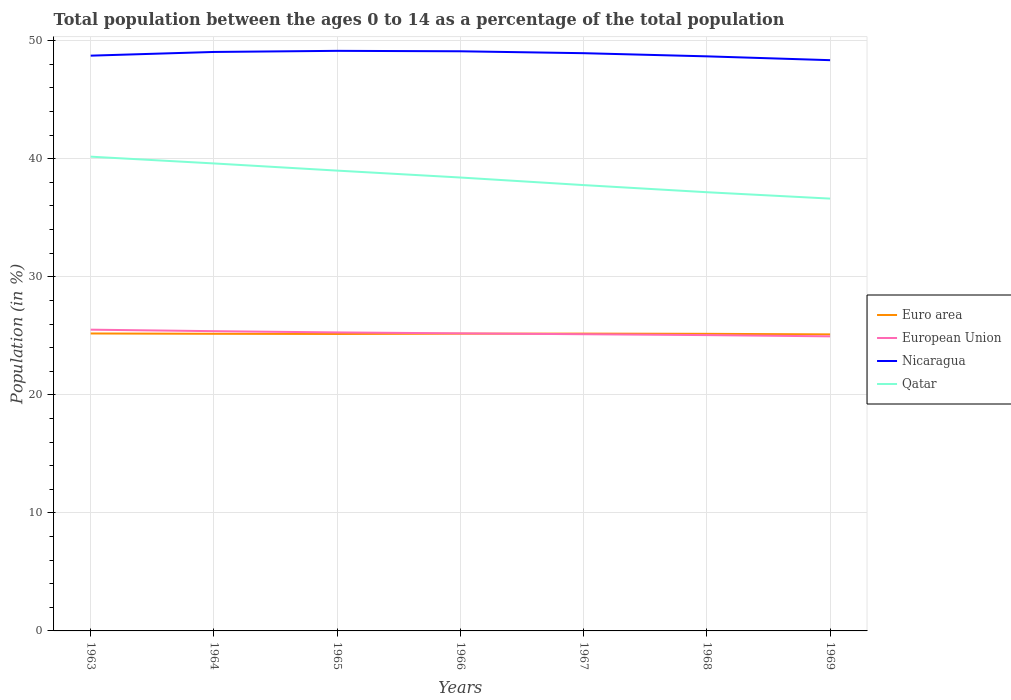Does the line corresponding to Nicaragua intersect with the line corresponding to European Union?
Your answer should be compact. No. Across all years, what is the maximum percentage of the population ages 0 to 14 in European Union?
Your answer should be compact. 24.96. In which year was the percentage of the population ages 0 to 14 in Euro area maximum?
Offer a terse response. 1969. What is the total percentage of the population ages 0 to 14 in Qatar in the graph?
Offer a terse response. 0.59. What is the difference between the highest and the second highest percentage of the population ages 0 to 14 in Nicaragua?
Your answer should be very brief. 0.79. How many lines are there?
Offer a very short reply. 4. How many years are there in the graph?
Ensure brevity in your answer.  7. Are the values on the major ticks of Y-axis written in scientific E-notation?
Keep it short and to the point. No. Does the graph contain any zero values?
Offer a very short reply. No. Where does the legend appear in the graph?
Your response must be concise. Center right. How many legend labels are there?
Your response must be concise. 4. What is the title of the graph?
Offer a terse response. Total population between the ages 0 to 14 as a percentage of the total population. Does "Peru" appear as one of the legend labels in the graph?
Provide a short and direct response. No. What is the Population (in %) of Euro area in 1963?
Provide a short and direct response. 25.2. What is the Population (in %) of European Union in 1963?
Your answer should be very brief. 25.52. What is the Population (in %) in Nicaragua in 1963?
Your answer should be compact. 48.74. What is the Population (in %) of Qatar in 1963?
Offer a very short reply. 40.18. What is the Population (in %) of Euro area in 1964?
Provide a succinct answer. 25.17. What is the Population (in %) in European Union in 1964?
Provide a short and direct response. 25.4. What is the Population (in %) in Nicaragua in 1964?
Your answer should be compact. 49.05. What is the Population (in %) in Qatar in 1964?
Give a very brief answer. 39.6. What is the Population (in %) in Euro area in 1965?
Offer a very short reply. 25.16. What is the Population (in %) of European Union in 1965?
Offer a very short reply. 25.29. What is the Population (in %) in Nicaragua in 1965?
Keep it short and to the point. 49.14. What is the Population (in %) in Qatar in 1965?
Your answer should be very brief. 39. What is the Population (in %) in Euro area in 1966?
Your answer should be compact. 25.18. What is the Population (in %) in European Union in 1966?
Provide a succinct answer. 25.21. What is the Population (in %) in Nicaragua in 1966?
Offer a terse response. 49.11. What is the Population (in %) of Qatar in 1966?
Ensure brevity in your answer.  38.41. What is the Population (in %) of Euro area in 1967?
Provide a succinct answer. 25.19. What is the Population (in %) of European Union in 1967?
Ensure brevity in your answer.  25.14. What is the Population (in %) in Nicaragua in 1967?
Your answer should be very brief. 48.95. What is the Population (in %) of Qatar in 1967?
Ensure brevity in your answer.  37.77. What is the Population (in %) of Euro area in 1968?
Your answer should be very brief. 25.17. What is the Population (in %) in European Union in 1968?
Offer a very short reply. 25.06. What is the Population (in %) of Nicaragua in 1968?
Provide a succinct answer. 48.68. What is the Population (in %) in Qatar in 1968?
Provide a succinct answer. 37.17. What is the Population (in %) in Euro area in 1969?
Offer a terse response. 25.12. What is the Population (in %) of European Union in 1969?
Provide a short and direct response. 24.96. What is the Population (in %) in Nicaragua in 1969?
Your response must be concise. 48.35. What is the Population (in %) of Qatar in 1969?
Give a very brief answer. 36.63. Across all years, what is the maximum Population (in %) of Euro area?
Your answer should be very brief. 25.2. Across all years, what is the maximum Population (in %) of European Union?
Provide a succinct answer. 25.52. Across all years, what is the maximum Population (in %) in Nicaragua?
Your answer should be very brief. 49.14. Across all years, what is the maximum Population (in %) of Qatar?
Offer a very short reply. 40.18. Across all years, what is the minimum Population (in %) of Euro area?
Offer a very short reply. 25.12. Across all years, what is the minimum Population (in %) of European Union?
Offer a terse response. 24.96. Across all years, what is the minimum Population (in %) in Nicaragua?
Offer a very short reply. 48.35. Across all years, what is the minimum Population (in %) in Qatar?
Make the answer very short. 36.63. What is the total Population (in %) in Euro area in the graph?
Your response must be concise. 176.19. What is the total Population (in %) of European Union in the graph?
Your answer should be very brief. 176.57. What is the total Population (in %) of Nicaragua in the graph?
Keep it short and to the point. 342.01. What is the total Population (in %) of Qatar in the graph?
Provide a short and direct response. 268.76. What is the difference between the Population (in %) of Euro area in 1963 and that in 1964?
Keep it short and to the point. 0.03. What is the difference between the Population (in %) of European Union in 1963 and that in 1964?
Ensure brevity in your answer.  0.13. What is the difference between the Population (in %) in Nicaragua in 1963 and that in 1964?
Your answer should be compact. -0.31. What is the difference between the Population (in %) in Qatar in 1963 and that in 1964?
Make the answer very short. 0.57. What is the difference between the Population (in %) of Euro area in 1963 and that in 1965?
Your answer should be very brief. 0.04. What is the difference between the Population (in %) in European Union in 1963 and that in 1965?
Give a very brief answer. 0.23. What is the difference between the Population (in %) in Nicaragua in 1963 and that in 1965?
Your response must be concise. -0.41. What is the difference between the Population (in %) of Qatar in 1963 and that in 1965?
Your answer should be compact. 1.18. What is the difference between the Population (in %) in Euro area in 1963 and that in 1966?
Your response must be concise. 0.02. What is the difference between the Population (in %) of European Union in 1963 and that in 1966?
Offer a very short reply. 0.31. What is the difference between the Population (in %) of Nicaragua in 1963 and that in 1966?
Offer a very short reply. -0.37. What is the difference between the Population (in %) of Qatar in 1963 and that in 1966?
Give a very brief answer. 1.77. What is the difference between the Population (in %) of Euro area in 1963 and that in 1967?
Make the answer very short. 0.01. What is the difference between the Population (in %) of European Union in 1963 and that in 1967?
Give a very brief answer. 0.39. What is the difference between the Population (in %) in Nicaragua in 1963 and that in 1967?
Your answer should be compact. -0.21. What is the difference between the Population (in %) in Qatar in 1963 and that in 1967?
Offer a very short reply. 2.41. What is the difference between the Population (in %) of Euro area in 1963 and that in 1968?
Your response must be concise. 0.03. What is the difference between the Population (in %) of European Union in 1963 and that in 1968?
Ensure brevity in your answer.  0.46. What is the difference between the Population (in %) in Nicaragua in 1963 and that in 1968?
Keep it short and to the point. 0.06. What is the difference between the Population (in %) of Qatar in 1963 and that in 1968?
Offer a terse response. 3.01. What is the difference between the Population (in %) in Euro area in 1963 and that in 1969?
Your answer should be very brief. 0.08. What is the difference between the Population (in %) in European Union in 1963 and that in 1969?
Give a very brief answer. 0.57. What is the difference between the Population (in %) of Nicaragua in 1963 and that in 1969?
Provide a succinct answer. 0.38. What is the difference between the Population (in %) in Qatar in 1963 and that in 1969?
Provide a succinct answer. 3.55. What is the difference between the Population (in %) in Euro area in 1964 and that in 1965?
Your response must be concise. 0.02. What is the difference between the Population (in %) in European Union in 1964 and that in 1965?
Your answer should be compact. 0.11. What is the difference between the Population (in %) of Nicaragua in 1964 and that in 1965?
Your answer should be compact. -0.09. What is the difference between the Population (in %) of Qatar in 1964 and that in 1965?
Provide a succinct answer. 0.61. What is the difference between the Population (in %) of Euro area in 1964 and that in 1966?
Keep it short and to the point. -0.01. What is the difference between the Population (in %) of European Union in 1964 and that in 1966?
Keep it short and to the point. 0.19. What is the difference between the Population (in %) of Nicaragua in 1964 and that in 1966?
Offer a terse response. -0.06. What is the difference between the Population (in %) of Qatar in 1964 and that in 1966?
Provide a short and direct response. 1.19. What is the difference between the Population (in %) of Euro area in 1964 and that in 1967?
Offer a terse response. -0.02. What is the difference between the Population (in %) of European Union in 1964 and that in 1967?
Your answer should be very brief. 0.26. What is the difference between the Population (in %) in Nicaragua in 1964 and that in 1967?
Keep it short and to the point. 0.1. What is the difference between the Population (in %) in Qatar in 1964 and that in 1967?
Offer a very short reply. 1.83. What is the difference between the Population (in %) of Euro area in 1964 and that in 1968?
Provide a short and direct response. 0. What is the difference between the Population (in %) in European Union in 1964 and that in 1968?
Offer a very short reply. 0.33. What is the difference between the Population (in %) in Nicaragua in 1964 and that in 1968?
Your answer should be compact. 0.37. What is the difference between the Population (in %) in Qatar in 1964 and that in 1968?
Your answer should be compact. 2.44. What is the difference between the Population (in %) in Euro area in 1964 and that in 1969?
Ensure brevity in your answer.  0.05. What is the difference between the Population (in %) of European Union in 1964 and that in 1969?
Provide a short and direct response. 0.44. What is the difference between the Population (in %) of Nicaragua in 1964 and that in 1969?
Provide a short and direct response. 0.7. What is the difference between the Population (in %) in Qatar in 1964 and that in 1969?
Ensure brevity in your answer.  2.98. What is the difference between the Population (in %) of Euro area in 1965 and that in 1966?
Give a very brief answer. -0.03. What is the difference between the Population (in %) in European Union in 1965 and that in 1966?
Provide a succinct answer. 0.08. What is the difference between the Population (in %) in Nicaragua in 1965 and that in 1966?
Your answer should be compact. 0.04. What is the difference between the Population (in %) in Qatar in 1965 and that in 1966?
Keep it short and to the point. 0.59. What is the difference between the Population (in %) of Euro area in 1965 and that in 1967?
Your response must be concise. -0.03. What is the difference between the Population (in %) in European Union in 1965 and that in 1967?
Your answer should be compact. 0.15. What is the difference between the Population (in %) in Nicaragua in 1965 and that in 1967?
Provide a succinct answer. 0.2. What is the difference between the Population (in %) in Qatar in 1965 and that in 1967?
Make the answer very short. 1.23. What is the difference between the Population (in %) of Euro area in 1965 and that in 1968?
Provide a short and direct response. -0.01. What is the difference between the Population (in %) in European Union in 1965 and that in 1968?
Offer a terse response. 0.23. What is the difference between the Population (in %) of Nicaragua in 1965 and that in 1968?
Offer a terse response. 0.47. What is the difference between the Population (in %) in Qatar in 1965 and that in 1968?
Ensure brevity in your answer.  1.83. What is the difference between the Population (in %) in Euro area in 1965 and that in 1969?
Your response must be concise. 0.03. What is the difference between the Population (in %) in European Union in 1965 and that in 1969?
Offer a very short reply. 0.33. What is the difference between the Population (in %) of Nicaragua in 1965 and that in 1969?
Provide a succinct answer. 0.79. What is the difference between the Population (in %) in Qatar in 1965 and that in 1969?
Your answer should be very brief. 2.37. What is the difference between the Population (in %) in Euro area in 1966 and that in 1967?
Make the answer very short. -0. What is the difference between the Population (in %) in European Union in 1966 and that in 1967?
Provide a short and direct response. 0.07. What is the difference between the Population (in %) of Nicaragua in 1966 and that in 1967?
Provide a short and direct response. 0.16. What is the difference between the Population (in %) of Qatar in 1966 and that in 1967?
Keep it short and to the point. 0.64. What is the difference between the Population (in %) in Euro area in 1966 and that in 1968?
Give a very brief answer. 0.01. What is the difference between the Population (in %) in European Union in 1966 and that in 1968?
Keep it short and to the point. 0.15. What is the difference between the Population (in %) in Nicaragua in 1966 and that in 1968?
Offer a terse response. 0.43. What is the difference between the Population (in %) of Qatar in 1966 and that in 1968?
Your response must be concise. 1.25. What is the difference between the Population (in %) of Euro area in 1966 and that in 1969?
Make the answer very short. 0.06. What is the difference between the Population (in %) of European Union in 1966 and that in 1969?
Provide a short and direct response. 0.25. What is the difference between the Population (in %) of Nicaragua in 1966 and that in 1969?
Make the answer very short. 0.75. What is the difference between the Population (in %) of Qatar in 1966 and that in 1969?
Ensure brevity in your answer.  1.79. What is the difference between the Population (in %) in Euro area in 1967 and that in 1968?
Ensure brevity in your answer.  0.02. What is the difference between the Population (in %) of European Union in 1967 and that in 1968?
Offer a very short reply. 0.08. What is the difference between the Population (in %) of Nicaragua in 1967 and that in 1968?
Give a very brief answer. 0.27. What is the difference between the Population (in %) of Qatar in 1967 and that in 1968?
Provide a short and direct response. 0.6. What is the difference between the Population (in %) in Euro area in 1967 and that in 1969?
Give a very brief answer. 0.07. What is the difference between the Population (in %) of European Union in 1967 and that in 1969?
Your answer should be very brief. 0.18. What is the difference between the Population (in %) in Nicaragua in 1967 and that in 1969?
Offer a terse response. 0.59. What is the difference between the Population (in %) of Qatar in 1967 and that in 1969?
Ensure brevity in your answer.  1.14. What is the difference between the Population (in %) of Euro area in 1968 and that in 1969?
Provide a succinct answer. 0.05. What is the difference between the Population (in %) of European Union in 1968 and that in 1969?
Ensure brevity in your answer.  0.1. What is the difference between the Population (in %) in Nicaragua in 1968 and that in 1969?
Your answer should be compact. 0.32. What is the difference between the Population (in %) of Qatar in 1968 and that in 1969?
Provide a short and direct response. 0.54. What is the difference between the Population (in %) of Euro area in 1963 and the Population (in %) of European Union in 1964?
Ensure brevity in your answer.  -0.2. What is the difference between the Population (in %) in Euro area in 1963 and the Population (in %) in Nicaragua in 1964?
Make the answer very short. -23.85. What is the difference between the Population (in %) of Euro area in 1963 and the Population (in %) of Qatar in 1964?
Ensure brevity in your answer.  -14.41. What is the difference between the Population (in %) in European Union in 1963 and the Population (in %) in Nicaragua in 1964?
Make the answer very short. -23.53. What is the difference between the Population (in %) in European Union in 1963 and the Population (in %) in Qatar in 1964?
Provide a succinct answer. -14.08. What is the difference between the Population (in %) in Nicaragua in 1963 and the Population (in %) in Qatar in 1964?
Provide a short and direct response. 9.13. What is the difference between the Population (in %) in Euro area in 1963 and the Population (in %) in European Union in 1965?
Give a very brief answer. -0.09. What is the difference between the Population (in %) of Euro area in 1963 and the Population (in %) of Nicaragua in 1965?
Your response must be concise. -23.94. What is the difference between the Population (in %) in Euro area in 1963 and the Population (in %) in Qatar in 1965?
Provide a short and direct response. -13.8. What is the difference between the Population (in %) of European Union in 1963 and the Population (in %) of Nicaragua in 1965?
Offer a terse response. -23.62. What is the difference between the Population (in %) in European Union in 1963 and the Population (in %) in Qatar in 1965?
Provide a short and direct response. -13.48. What is the difference between the Population (in %) in Nicaragua in 1963 and the Population (in %) in Qatar in 1965?
Provide a succinct answer. 9.74. What is the difference between the Population (in %) in Euro area in 1963 and the Population (in %) in European Union in 1966?
Ensure brevity in your answer.  -0.01. What is the difference between the Population (in %) of Euro area in 1963 and the Population (in %) of Nicaragua in 1966?
Make the answer very short. -23.91. What is the difference between the Population (in %) in Euro area in 1963 and the Population (in %) in Qatar in 1966?
Ensure brevity in your answer.  -13.21. What is the difference between the Population (in %) in European Union in 1963 and the Population (in %) in Nicaragua in 1966?
Provide a succinct answer. -23.58. What is the difference between the Population (in %) of European Union in 1963 and the Population (in %) of Qatar in 1966?
Offer a terse response. -12.89. What is the difference between the Population (in %) in Nicaragua in 1963 and the Population (in %) in Qatar in 1966?
Your answer should be very brief. 10.32. What is the difference between the Population (in %) of Euro area in 1963 and the Population (in %) of European Union in 1967?
Ensure brevity in your answer.  0.06. What is the difference between the Population (in %) in Euro area in 1963 and the Population (in %) in Nicaragua in 1967?
Your response must be concise. -23.75. What is the difference between the Population (in %) in Euro area in 1963 and the Population (in %) in Qatar in 1967?
Ensure brevity in your answer.  -12.57. What is the difference between the Population (in %) of European Union in 1963 and the Population (in %) of Nicaragua in 1967?
Your response must be concise. -23.42. What is the difference between the Population (in %) in European Union in 1963 and the Population (in %) in Qatar in 1967?
Your response must be concise. -12.25. What is the difference between the Population (in %) of Nicaragua in 1963 and the Population (in %) of Qatar in 1967?
Your response must be concise. 10.97. What is the difference between the Population (in %) in Euro area in 1963 and the Population (in %) in European Union in 1968?
Keep it short and to the point. 0.14. What is the difference between the Population (in %) in Euro area in 1963 and the Population (in %) in Nicaragua in 1968?
Provide a short and direct response. -23.48. What is the difference between the Population (in %) of Euro area in 1963 and the Population (in %) of Qatar in 1968?
Ensure brevity in your answer.  -11.97. What is the difference between the Population (in %) in European Union in 1963 and the Population (in %) in Nicaragua in 1968?
Your answer should be very brief. -23.15. What is the difference between the Population (in %) of European Union in 1963 and the Population (in %) of Qatar in 1968?
Provide a short and direct response. -11.64. What is the difference between the Population (in %) in Nicaragua in 1963 and the Population (in %) in Qatar in 1968?
Keep it short and to the point. 11.57. What is the difference between the Population (in %) in Euro area in 1963 and the Population (in %) in European Union in 1969?
Keep it short and to the point. 0.24. What is the difference between the Population (in %) of Euro area in 1963 and the Population (in %) of Nicaragua in 1969?
Give a very brief answer. -23.15. What is the difference between the Population (in %) of Euro area in 1963 and the Population (in %) of Qatar in 1969?
Ensure brevity in your answer.  -11.43. What is the difference between the Population (in %) in European Union in 1963 and the Population (in %) in Nicaragua in 1969?
Provide a short and direct response. -22.83. What is the difference between the Population (in %) in European Union in 1963 and the Population (in %) in Qatar in 1969?
Offer a very short reply. -11.1. What is the difference between the Population (in %) of Nicaragua in 1963 and the Population (in %) of Qatar in 1969?
Offer a very short reply. 12.11. What is the difference between the Population (in %) of Euro area in 1964 and the Population (in %) of European Union in 1965?
Ensure brevity in your answer.  -0.12. What is the difference between the Population (in %) in Euro area in 1964 and the Population (in %) in Nicaragua in 1965?
Provide a short and direct response. -23.97. What is the difference between the Population (in %) of Euro area in 1964 and the Population (in %) of Qatar in 1965?
Provide a succinct answer. -13.83. What is the difference between the Population (in %) in European Union in 1964 and the Population (in %) in Nicaragua in 1965?
Your response must be concise. -23.75. What is the difference between the Population (in %) in European Union in 1964 and the Population (in %) in Qatar in 1965?
Provide a short and direct response. -13.6. What is the difference between the Population (in %) of Nicaragua in 1964 and the Population (in %) of Qatar in 1965?
Provide a short and direct response. 10.05. What is the difference between the Population (in %) of Euro area in 1964 and the Population (in %) of European Union in 1966?
Offer a very short reply. -0.04. What is the difference between the Population (in %) in Euro area in 1964 and the Population (in %) in Nicaragua in 1966?
Provide a succinct answer. -23.93. What is the difference between the Population (in %) of Euro area in 1964 and the Population (in %) of Qatar in 1966?
Offer a very short reply. -13.24. What is the difference between the Population (in %) of European Union in 1964 and the Population (in %) of Nicaragua in 1966?
Offer a terse response. -23.71. What is the difference between the Population (in %) in European Union in 1964 and the Population (in %) in Qatar in 1966?
Ensure brevity in your answer.  -13.02. What is the difference between the Population (in %) in Nicaragua in 1964 and the Population (in %) in Qatar in 1966?
Ensure brevity in your answer.  10.64. What is the difference between the Population (in %) in Euro area in 1964 and the Population (in %) in European Union in 1967?
Your answer should be compact. 0.04. What is the difference between the Population (in %) in Euro area in 1964 and the Population (in %) in Nicaragua in 1967?
Provide a succinct answer. -23.77. What is the difference between the Population (in %) of Euro area in 1964 and the Population (in %) of Qatar in 1967?
Your answer should be very brief. -12.6. What is the difference between the Population (in %) in European Union in 1964 and the Population (in %) in Nicaragua in 1967?
Make the answer very short. -23.55. What is the difference between the Population (in %) of European Union in 1964 and the Population (in %) of Qatar in 1967?
Make the answer very short. -12.37. What is the difference between the Population (in %) in Nicaragua in 1964 and the Population (in %) in Qatar in 1967?
Provide a short and direct response. 11.28. What is the difference between the Population (in %) of Euro area in 1964 and the Population (in %) of European Union in 1968?
Provide a short and direct response. 0.11. What is the difference between the Population (in %) in Euro area in 1964 and the Population (in %) in Nicaragua in 1968?
Keep it short and to the point. -23.5. What is the difference between the Population (in %) in Euro area in 1964 and the Population (in %) in Qatar in 1968?
Your answer should be compact. -11.99. What is the difference between the Population (in %) of European Union in 1964 and the Population (in %) of Nicaragua in 1968?
Your answer should be very brief. -23.28. What is the difference between the Population (in %) of European Union in 1964 and the Population (in %) of Qatar in 1968?
Ensure brevity in your answer.  -11.77. What is the difference between the Population (in %) in Nicaragua in 1964 and the Population (in %) in Qatar in 1968?
Keep it short and to the point. 11.88. What is the difference between the Population (in %) in Euro area in 1964 and the Population (in %) in European Union in 1969?
Provide a succinct answer. 0.22. What is the difference between the Population (in %) in Euro area in 1964 and the Population (in %) in Nicaragua in 1969?
Your answer should be compact. -23.18. What is the difference between the Population (in %) of Euro area in 1964 and the Population (in %) of Qatar in 1969?
Make the answer very short. -11.45. What is the difference between the Population (in %) of European Union in 1964 and the Population (in %) of Nicaragua in 1969?
Provide a succinct answer. -22.96. What is the difference between the Population (in %) of European Union in 1964 and the Population (in %) of Qatar in 1969?
Your answer should be very brief. -11.23. What is the difference between the Population (in %) of Nicaragua in 1964 and the Population (in %) of Qatar in 1969?
Provide a succinct answer. 12.42. What is the difference between the Population (in %) in Euro area in 1965 and the Population (in %) in European Union in 1966?
Offer a very short reply. -0.05. What is the difference between the Population (in %) in Euro area in 1965 and the Population (in %) in Nicaragua in 1966?
Keep it short and to the point. -23.95. What is the difference between the Population (in %) of Euro area in 1965 and the Population (in %) of Qatar in 1966?
Provide a short and direct response. -13.26. What is the difference between the Population (in %) in European Union in 1965 and the Population (in %) in Nicaragua in 1966?
Provide a short and direct response. -23.82. What is the difference between the Population (in %) of European Union in 1965 and the Population (in %) of Qatar in 1966?
Your response must be concise. -13.12. What is the difference between the Population (in %) of Nicaragua in 1965 and the Population (in %) of Qatar in 1966?
Your response must be concise. 10.73. What is the difference between the Population (in %) of Euro area in 1965 and the Population (in %) of European Union in 1967?
Make the answer very short. 0.02. What is the difference between the Population (in %) of Euro area in 1965 and the Population (in %) of Nicaragua in 1967?
Offer a terse response. -23.79. What is the difference between the Population (in %) in Euro area in 1965 and the Population (in %) in Qatar in 1967?
Ensure brevity in your answer.  -12.61. What is the difference between the Population (in %) in European Union in 1965 and the Population (in %) in Nicaragua in 1967?
Provide a succinct answer. -23.66. What is the difference between the Population (in %) in European Union in 1965 and the Population (in %) in Qatar in 1967?
Provide a short and direct response. -12.48. What is the difference between the Population (in %) of Nicaragua in 1965 and the Population (in %) of Qatar in 1967?
Provide a succinct answer. 11.37. What is the difference between the Population (in %) in Euro area in 1965 and the Population (in %) in European Union in 1968?
Provide a succinct answer. 0.09. What is the difference between the Population (in %) of Euro area in 1965 and the Population (in %) of Nicaragua in 1968?
Give a very brief answer. -23.52. What is the difference between the Population (in %) of Euro area in 1965 and the Population (in %) of Qatar in 1968?
Provide a short and direct response. -12.01. What is the difference between the Population (in %) of European Union in 1965 and the Population (in %) of Nicaragua in 1968?
Offer a terse response. -23.39. What is the difference between the Population (in %) in European Union in 1965 and the Population (in %) in Qatar in 1968?
Keep it short and to the point. -11.88. What is the difference between the Population (in %) of Nicaragua in 1965 and the Population (in %) of Qatar in 1968?
Ensure brevity in your answer.  11.98. What is the difference between the Population (in %) in Euro area in 1965 and the Population (in %) in European Union in 1969?
Your response must be concise. 0.2. What is the difference between the Population (in %) of Euro area in 1965 and the Population (in %) of Nicaragua in 1969?
Provide a succinct answer. -23.2. What is the difference between the Population (in %) in Euro area in 1965 and the Population (in %) in Qatar in 1969?
Your answer should be very brief. -11.47. What is the difference between the Population (in %) in European Union in 1965 and the Population (in %) in Nicaragua in 1969?
Keep it short and to the point. -23.06. What is the difference between the Population (in %) of European Union in 1965 and the Population (in %) of Qatar in 1969?
Offer a terse response. -11.34. What is the difference between the Population (in %) in Nicaragua in 1965 and the Population (in %) in Qatar in 1969?
Offer a terse response. 12.52. What is the difference between the Population (in %) in Euro area in 1966 and the Population (in %) in European Union in 1967?
Give a very brief answer. 0.05. What is the difference between the Population (in %) of Euro area in 1966 and the Population (in %) of Nicaragua in 1967?
Make the answer very short. -23.76. What is the difference between the Population (in %) of Euro area in 1966 and the Population (in %) of Qatar in 1967?
Your response must be concise. -12.59. What is the difference between the Population (in %) of European Union in 1966 and the Population (in %) of Nicaragua in 1967?
Offer a terse response. -23.74. What is the difference between the Population (in %) of European Union in 1966 and the Population (in %) of Qatar in 1967?
Provide a short and direct response. -12.56. What is the difference between the Population (in %) in Nicaragua in 1966 and the Population (in %) in Qatar in 1967?
Your response must be concise. 11.34. What is the difference between the Population (in %) of Euro area in 1966 and the Population (in %) of European Union in 1968?
Your answer should be compact. 0.12. What is the difference between the Population (in %) in Euro area in 1966 and the Population (in %) in Nicaragua in 1968?
Keep it short and to the point. -23.49. What is the difference between the Population (in %) of Euro area in 1966 and the Population (in %) of Qatar in 1968?
Give a very brief answer. -11.98. What is the difference between the Population (in %) in European Union in 1966 and the Population (in %) in Nicaragua in 1968?
Provide a succinct answer. -23.47. What is the difference between the Population (in %) in European Union in 1966 and the Population (in %) in Qatar in 1968?
Give a very brief answer. -11.96. What is the difference between the Population (in %) of Nicaragua in 1966 and the Population (in %) of Qatar in 1968?
Your answer should be very brief. 11.94. What is the difference between the Population (in %) of Euro area in 1966 and the Population (in %) of European Union in 1969?
Give a very brief answer. 0.23. What is the difference between the Population (in %) of Euro area in 1966 and the Population (in %) of Nicaragua in 1969?
Your response must be concise. -23.17. What is the difference between the Population (in %) of Euro area in 1966 and the Population (in %) of Qatar in 1969?
Give a very brief answer. -11.44. What is the difference between the Population (in %) in European Union in 1966 and the Population (in %) in Nicaragua in 1969?
Ensure brevity in your answer.  -23.14. What is the difference between the Population (in %) in European Union in 1966 and the Population (in %) in Qatar in 1969?
Offer a very short reply. -11.42. What is the difference between the Population (in %) of Nicaragua in 1966 and the Population (in %) of Qatar in 1969?
Your answer should be compact. 12.48. What is the difference between the Population (in %) in Euro area in 1967 and the Population (in %) in European Union in 1968?
Keep it short and to the point. 0.13. What is the difference between the Population (in %) of Euro area in 1967 and the Population (in %) of Nicaragua in 1968?
Your answer should be compact. -23.49. What is the difference between the Population (in %) in Euro area in 1967 and the Population (in %) in Qatar in 1968?
Offer a terse response. -11.98. What is the difference between the Population (in %) of European Union in 1967 and the Population (in %) of Nicaragua in 1968?
Offer a terse response. -23.54. What is the difference between the Population (in %) in European Union in 1967 and the Population (in %) in Qatar in 1968?
Provide a short and direct response. -12.03. What is the difference between the Population (in %) of Nicaragua in 1967 and the Population (in %) of Qatar in 1968?
Provide a short and direct response. 11.78. What is the difference between the Population (in %) in Euro area in 1967 and the Population (in %) in European Union in 1969?
Provide a short and direct response. 0.23. What is the difference between the Population (in %) of Euro area in 1967 and the Population (in %) of Nicaragua in 1969?
Your answer should be compact. -23.17. What is the difference between the Population (in %) of Euro area in 1967 and the Population (in %) of Qatar in 1969?
Your answer should be very brief. -11.44. What is the difference between the Population (in %) in European Union in 1967 and the Population (in %) in Nicaragua in 1969?
Keep it short and to the point. -23.22. What is the difference between the Population (in %) in European Union in 1967 and the Population (in %) in Qatar in 1969?
Provide a short and direct response. -11.49. What is the difference between the Population (in %) of Nicaragua in 1967 and the Population (in %) of Qatar in 1969?
Make the answer very short. 12.32. What is the difference between the Population (in %) in Euro area in 1968 and the Population (in %) in European Union in 1969?
Your answer should be compact. 0.21. What is the difference between the Population (in %) of Euro area in 1968 and the Population (in %) of Nicaragua in 1969?
Keep it short and to the point. -23.18. What is the difference between the Population (in %) of Euro area in 1968 and the Population (in %) of Qatar in 1969?
Provide a short and direct response. -11.46. What is the difference between the Population (in %) in European Union in 1968 and the Population (in %) in Nicaragua in 1969?
Ensure brevity in your answer.  -23.29. What is the difference between the Population (in %) in European Union in 1968 and the Population (in %) in Qatar in 1969?
Make the answer very short. -11.56. What is the difference between the Population (in %) in Nicaragua in 1968 and the Population (in %) in Qatar in 1969?
Make the answer very short. 12.05. What is the average Population (in %) in Euro area per year?
Your answer should be compact. 25.17. What is the average Population (in %) in European Union per year?
Offer a terse response. 25.22. What is the average Population (in %) of Nicaragua per year?
Give a very brief answer. 48.86. What is the average Population (in %) of Qatar per year?
Your answer should be very brief. 38.39. In the year 1963, what is the difference between the Population (in %) of Euro area and Population (in %) of European Union?
Your answer should be very brief. -0.32. In the year 1963, what is the difference between the Population (in %) in Euro area and Population (in %) in Nicaragua?
Offer a very short reply. -23.54. In the year 1963, what is the difference between the Population (in %) in Euro area and Population (in %) in Qatar?
Provide a succinct answer. -14.98. In the year 1963, what is the difference between the Population (in %) of European Union and Population (in %) of Nicaragua?
Provide a succinct answer. -23.21. In the year 1963, what is the difference between the Population (in %) in European Union and Population (in %) in Qatar?
Your answer should be very brief. -14.66. In the year 1963, what is the difference between the Population (in %) of Nicaragua and Population (in %) of Qatar?
Offer a terse response. 8.56. In the year 1964, what is the difference between the Population (in %) of Euro area and Population (in %) of European Union?
Your answer should be very brief. -0.22. In the year 1964, what is the difference between the Population (in %) of Euro area and Population (in %) of Nicaragua?
Provide a succinct answer. -23.88. In the year 1964, what is the difference between the Population (in %) in Euro area and Population (in %) in Qatar?
Your answer should be compact. -14.43. In the year 1964, what is the difference between the Population (in %) in European Union and Population (in %) in Nicaragua?
Offer a very short reply. -23.65. In the year 1964, what is the difference between the Population (in %) of European Union and Population (in %) of Qatar?
Your response must be concise. -14.21. In the year 1964, what is the difference between the Population (in %) of Nicaragua and Population (in %) of Qatar?
Offer a terse response. 9.44. In the year 1965, what is the difference between the Population (in %) in Euro area and Population (in %) in European Union?
Provide a short and direct response. -0.13. In the year 1965, what is the difference between the Population (in %) in Euro area and Population (in %) in Nicaragua?
Give a very brief answer. -23.99. In the year 1965, what is the difference between the Population (in %) of Euro area and Population (in %) of Qatar?
Make the answer very short. -13.84. In the year 1965, what is the difference between the Population (in %) of European Union and Population (in %) of Nicaragua?
Your answer should be compact. -23.86. In the year 1965, what is the difference between the Population (in %) in European Union and Population (in %) in Qatar?
Offer a terse response. -13.71. In the year 1965, what is the difference between the Population (in %) in Nicaragua and Population (in %) in Qatar?
Keep it short and to the point. 10.15. In the year 1966, what is the difference between the Population (in %) in Euro area and Population (in %) in European Union?
Make the answer very short. -0.03. In the year 1966, what is the difference between the Population (in %) in Euro area and Population (in %) in Nicaragua?
Provide a short and direct response. -23.92. In the year 1966, what is the difference between the Population (in %) of Euro area and Population (in %) of Qatar?
Give a very brief answer. -13.23. In the year 1966, what is the difference between the Population (in %) in European Union and Population (in %) in Nicaragua?
Your answer should be very brief. -23.9. In the year 1966, what is the difference between the Population (in %) of European Union and Population (in %) of Qatar?
Give a very brief answer. -13.2. In the year 1966, what is the difference between the Population (in %) in Nicaragua and Population (in %) in Qatar?
Provide a short and direct response. 10.69. In the year 1967, what is the difference between the Population (in %) of Euro area and Population (in %) of European Union?
Provide a short and direct response. 0.05. In the year 1967, what is the difference between the Population (in %) in Euro area and Population (in %) in Nicaragua?
Make the answer very short. -23.76. In the year 1967, what is the difference between the Population (in %) in Euro area and Population (in %) in Qatar?
Offer a very short reply. -12.58. In the year 1967, what is the difference between the Population (in %) in European Union and Population (in %) in Nicaragua?
Your answer should be very brief. -23.81. In the year 1967, what is the difference between the Population (in %) in European Union and Population (in %) in Qatar?
Your response must be concise. -12.63. In the year 1967, what is the difference between the Population (in %) of Nicaragua and Population (in %) of Qatar?
Provide a succinct answer. 11.18. In the year 1968, what is the difference between the Population (in %) in Euro area and Population (in %) in European Union?
Make the answer very short. 0.11. In the year 1968, what is the difference between the Population (in %) in Euro area and Population (in %) in Nicaragua?
Offer a very short reply. -23.51. In the year 1968, what is the difference between the Population (in %) of Euro area and Population (in %) of Qatar?
Offer a terse response. -12. In the year 1968, what is the difference between the Population (in %) in European Union and Population (in %) in Nicaragua?
Provide a succinct answer. -23.62. In the year 1968, what is the difference between the Population (in %) in European Union and Population (in %) in Qatar?
Your answer should be very brief. -12.11. In the year 1968, what is the difference between the Population (in %) in Nicaragua and Population (in %) in Qatar?
Your answer should be very brief. 11.51. In the year 1969, what is the difference between the Population (in %) in Euro area and Population (in %) in European Union?
Offer a terse response. 0.17. In the year 1969, what is the difference between the Population (in %) of Euro area and Population (in %) of Nicaragua?
Your response must be concise. -23.23. In the year 1969, what is the difference between the Population (in %) in Euro area and Population (in %) in Qatar?
Provide a short and direct response. -11.5. In the year 1969, what is the difference between the Population (in %) of European Union and Population (in %) of Nicaragua?
Your response must be concise. -23.4. In the year 1969, what is the difference between the Population (in %) in European Union and Population (in %) in Qatar?
Your response must be concise. -11.67. In the year 1969, what is the difference between the Population (in %) of Nicaragua and Population (in %) of Qatar?
Provide a succinct answer. 11.73. What is the ratio of the Population (in %) in Euro area in 1963 to that in 1964?
Ensure brevity in your answer.  1. What is the ratio of the Population (in %) in European Union in 1963 to that in 1964?
Make the answer very short. 1. What is the ratio of the Population (in %) of Qatar in 1963 to that in 1964?
Your response must be concise. 1.01. What is the ratio of the Population (in %) in Euro area in 1963 to that in 1965?
Keep it short and to the point. 1. What is the ratio of the Population (in %) in European Union in 1963 to that in 1965?
Give a very brief answer. 1.01. What is the ratio of the Population (in %) of Nicaragua in 1963 to that in 1965?
Keep it short and to the point. 0.99. What is the ratio of the Population (in %) in Qatar in 1963 to that in 1965?
Provide a short and direct response. 1.03. What is the ratio of the Population (in %) in Euro area in 1963 to that in 1966?
Your response must be concise. 1. What is the ratio of the Population (in %) of European Union in 1963 to that in 1966?
Give a very brief answer. 1.01. What is the ratio of the Population (in %) of Nicaragua in 1963 to that in 1966?
Offer a very short reply. 0.99. What is the ratio of the Population (in %) of Qatar in 1963 to that in 1966?
Offer a very short reply. 1.05. What is the ratio of the Population (in %) in Euro area in 1963 to that in 1967?
Make the answer very short. 1. What is the ratio of the Population (in %) of European Union in 1963 to that in 1967?
Your response must be concise. 1.02. What is the ratio of the Population (in %) in Nicaragua in 1963 to that in 1967?
Provide a succinct answer. 1. What is the ratio of the Population (in %) of Qatar in 1963 to that in 1967?
Offer a very short reply. 1.06. What is the ratio of the Population (in %) in Euro area in 1963 to that in 1968?
Ensure brevity in your answer.  1. What is the ratio of the Population (in %) in European Union in 1963 to that in 1968?
Provide a short and direct response. 1.02. What is the ratio of the Population (in %) in Nicaragua in 1963 to that in 1968?
Your response must be concise. 1. What is the ratio of the Population (in %) of Qatar in 1963 to that in 1968?
Provide a short and direct response. 1.08. What is the ratio of the Population (in %) in European Union in 1963 to that in 1969?
Your answer should be compact. 1.02. What is the ratio of the Population (in %) of Nicaragua in 1963 to that in 1969?
Your answer should be very brief. 1.01. What is the ratio of the Population (in %) in Qatar in 1963 to that in 1969?
Provide a succinct answer. 1.1. What is the ratio of the Population (in %) in Euro area in 1964 to that in 1965?
Make the answer very short. 1. What is the ratio of the Population (in %) in European Union in 1964 to that in 1965?
Give a very brief answer. 1. What is the ratio of the Population (in %) in Nicaragua in 1964 to that in 1965?
Keep it short and to the point. 1. What is the ratio of the Population (in %) of Qatar in 1964 to that in 1965?
Your response must be concise. 1.02. What is the ratio of the Population (in %) of Euro area in 1964 to that in 1966?
Make the answer very short. 1. What is the ratio of the Population (in %) of European Union in 1964 to that in 1966?
Keep it short and to the point. 1.01. What is the ratio of the Population (in %) in Nicaragua in 1964 to that in 1966?
Give a very brief answer. 1. What is the ratio of the Population (in %) of Qatar in 1964 to that in 1966?
Offer a very short reply. 1.03. What is the ratio of the Population (in %) of European Union in 1964 to that in 1967?
Keep it short and to the point. 1.01. What is the ratio of the Population (in %) in Qatar in 1964 to that in 1967?
Give a very brief answer. 1.05. What is the ratio of the Population (in %) of European Union in 1964 to that in 1968?
Provide a succinct answer. 1.01. What is the ratio of the Population (in %) of Nicaragua in 1964 to that in 1968?
Give a very brief answer. 1.01. What is the ratio of the Population (in %) in Qatar in 1964 to that in 1968?
Offer a terse response. 1.07. What is the ratio of the Population (in %) of European Union in 1964 to that in 1969?
Provide a succinct answer. 1.02. What is the ratio of the Population (in %) of Nicaragua in 1964 to that in 1969?
Your answer should be compact. 1.01. What is the ratio of the Population (in %) in Qatar in 1964 to that in 1969?
Give a very brief answer. 1.08. What is the ratio of the Population (in %) of Euro area in 1965 to that in 1966?
Your response must be concise. 1. What is the ratio of the Population (in %) in European Union in 1965 to that in 1966?
Give a very brief answer. 1. What is the ratio of the Population (in %) of Nicaragua in 1965 to that in 1966?
Provide a succinct answer. 1. What is the ratio of the Population (in %) in Qatar in 1965 to that in 1966?
Offer a very short reply. 1.02. What is the ratio of the Population (in %) in Qatar in 1965 to that in 1967?
Your response must be concise. 1.03. What is the ratio of the Population (in %) of Euro area in 1965 to that in 1968?
Offer a very short reply. 1. What is the ratio of the Population (in %) in Nicaragua in 1965 to that in 1968?
Keep it short and to the point. 1.01. What is the ratio of the Population (in %) of Qatar in 1965 to that in 1968?
Keep it short and to the point. 1.05. What is the ratio of the Population (in %) in Euro area in 1965 to that in 1969?
Your answer should be compact. 1. What is the ratio of the Population (in %) in European Union in 1965 to that in 1969?
Give a very brief answer. 1.01. What is the ratio of the Population (in %) in Nicaragua in 1965 to that in 1969?
Keep it short and to the point. 1.02. What is the ratio of the Population (in %) in Qatar in 1965 to that in 1969?
Give a very brief answer. 1.06. What is the ratio of the Population (in %) of Euro area in 1966 to that in 1967?
Keep it short and to the point. 1. What is the ratio of the Population (in %) in European Union in 1966 to that in 1967?
Provide a succinct answer. 1. What is the ratio of the Population (in %) of Qatar in 1966 to that in 1967?
Give a very brief answer. 1.02. What is the ratio of the Population (in %) in European Union in 1966 to that in 1968?
Offer a terse response. 1.01. What is the ratio of the Population (in %) in Nicaragua in 1966 to that in 1968?
Provide a succinct answer. 1.01. What is the ratio of the Population (in %) in Qatar in 1966 to that in 1968?
Your answer should be very brief. 1.03. What is the ratio of the Population (in %) in Euro area in 1966 to that in 1969?
Make the answer very short. 1. What is the ratio of the Population (in %) of Nicaragua in 1966 to that in 1969?
Your response must be concise. 1.02. What is the ratio of the Population (in %) of Qatar in 1966 to that in 1969?
Provide a short and direct response. 1.05. What is the ratio of the Population (in %) in Euro area in 1967 to that in 1968?
Your response must be concise. 1. What is the ratio of the Population (in %) in Qatar in 1967 to that in 1968?
Make the answer very short. 1.02. What is the ratio of the Population (in %) of Euro area in 1967 to that in 1969?
Offer a terse response. 1. What is the ratio of the Population (in %) of Nicaragua in 1967 to that in 1969?
Your answer should be very brief. 1.01. What is the ratio of the Population (in %) of Qatar in 1967 to that in 1969?
Keep it short and to the point. 1.03. What is the ratio of the Population (in %) in Euro area in 1968 to that in 1969?
Offer a terse response. 1. What is the ratio of the Population (in %) in European Union in 1968 to that in 1969?
Your answer should be compact. 1. What is the ratio of the Population (in %) in Qatar in 1968 to that in 1969?
Provide a succinct answer. 1.01. What is the difference between the highest and the second highest Population (in %) in Euro area?
Keep it short and to the point. 0.01. What is the difference between the highest and the second highest Population (in %) of European Union?
Keep it short and to the point. 0.13. What is the difference between the highest and the second highest Population (in %) in Nicaragua?
Make the answer very short. 0.04. What is the difference between the highest and the second highest Population (in %) in Qatar?
Ensure brevity in your answer.  0.57. What is the difference between the highest and the lowest Population (in %) of Euro area?
Give a very brief answer. 0.08. What is the difference between the highest and the lowest Population (in %) in European Union?
Keep it short and to the point. 0.57. What is the difference between the highest and the lowest Population (in %) in Nicaragua?
Your response must be concise. 0.79. What is the difference between the highest and the lowest Population (in %) in Qatar?
Provide a succinct answer. 3.55. 